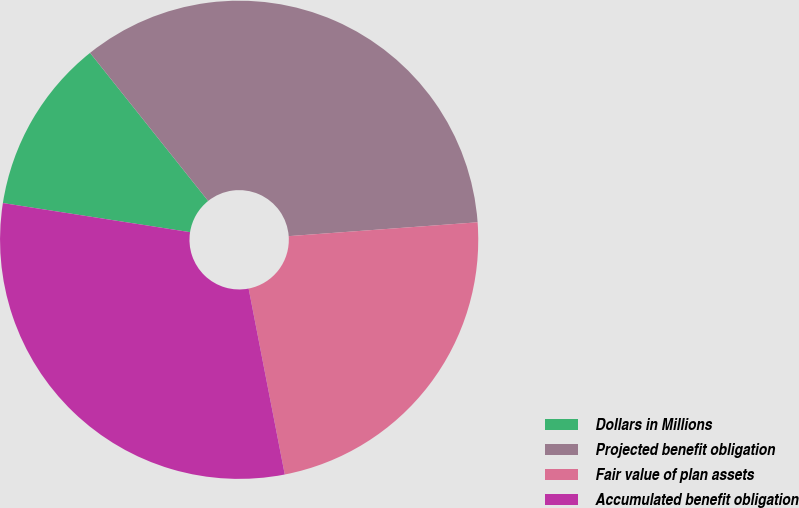Convert chart to OTSL. <chart><loc_0><loc_0><loc_500><loc_500><pie_chart><fcel>Dollars in Millions<fcel>Projected benefit obligation<fcel>Fair value of plan assets<fcel>Accumulated benefit obligation<nl><fcel>11.83%<fcel>34.55%<fcel>23.11%<fcel>30.51%<nl></chart> 